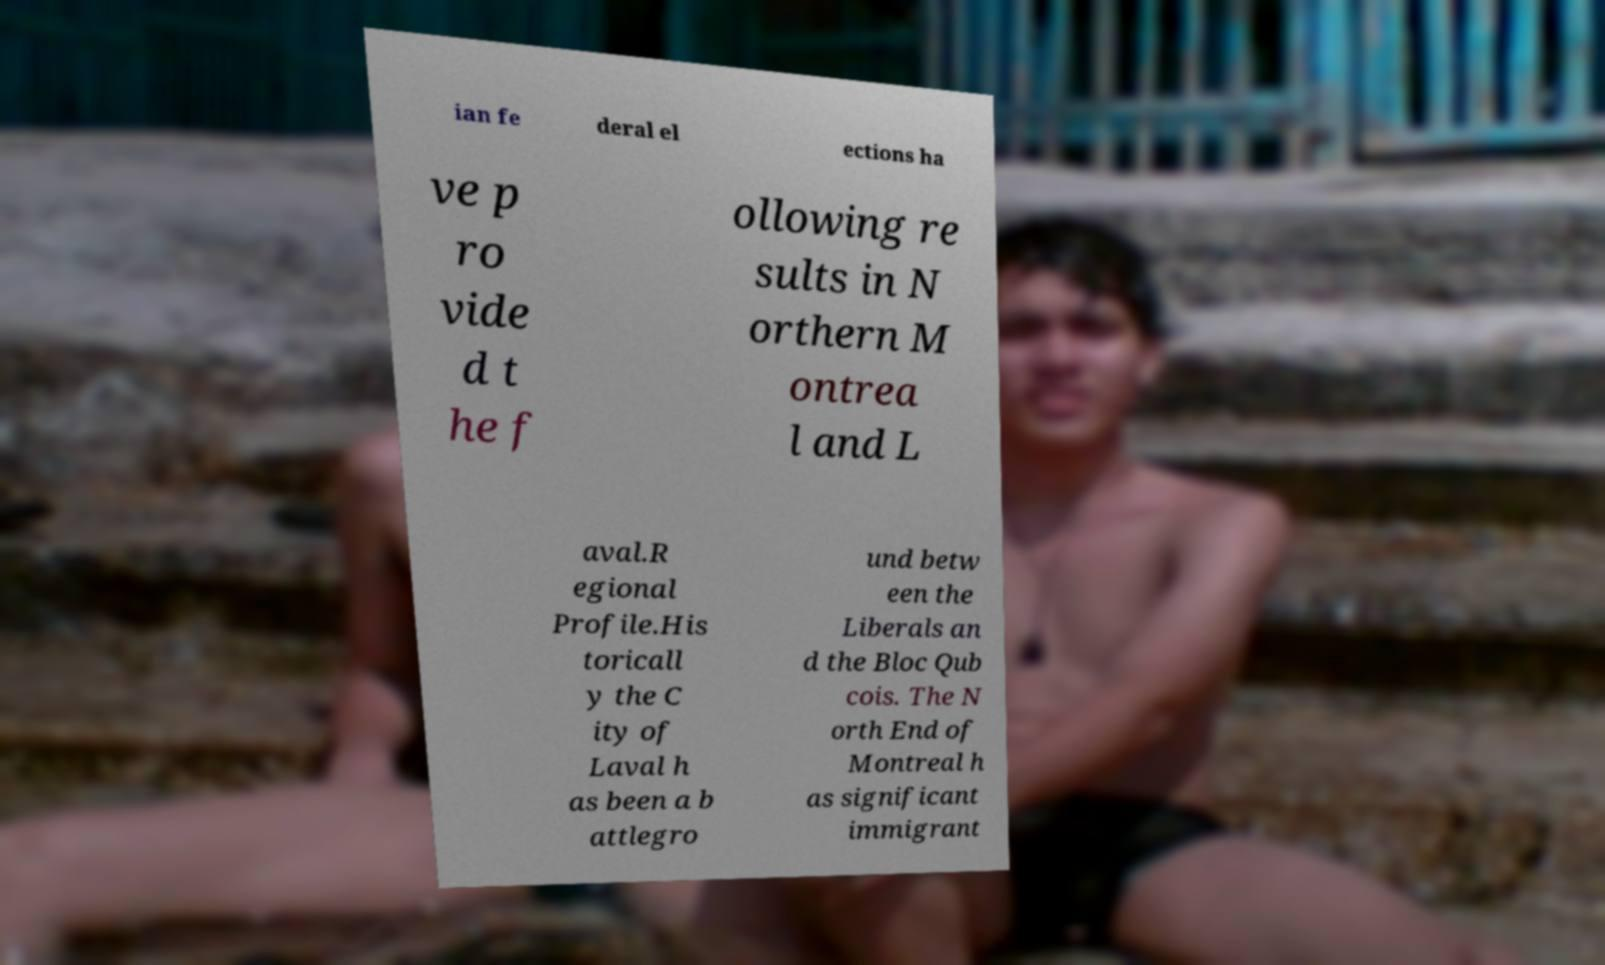For documentation purposes, I need the text within this image transcribed. Could you provide that? ian fe deral el ections ha ve p ro vide d t he f ollowing re sults in N orthern M ontrea l and L aval.R egional Profile.His toricall y the C ity of Laval h as been a b attlegro und betw een the Liberals an d the Bloc Qub cois. The N orth End of Montreal h as significant immigrant 